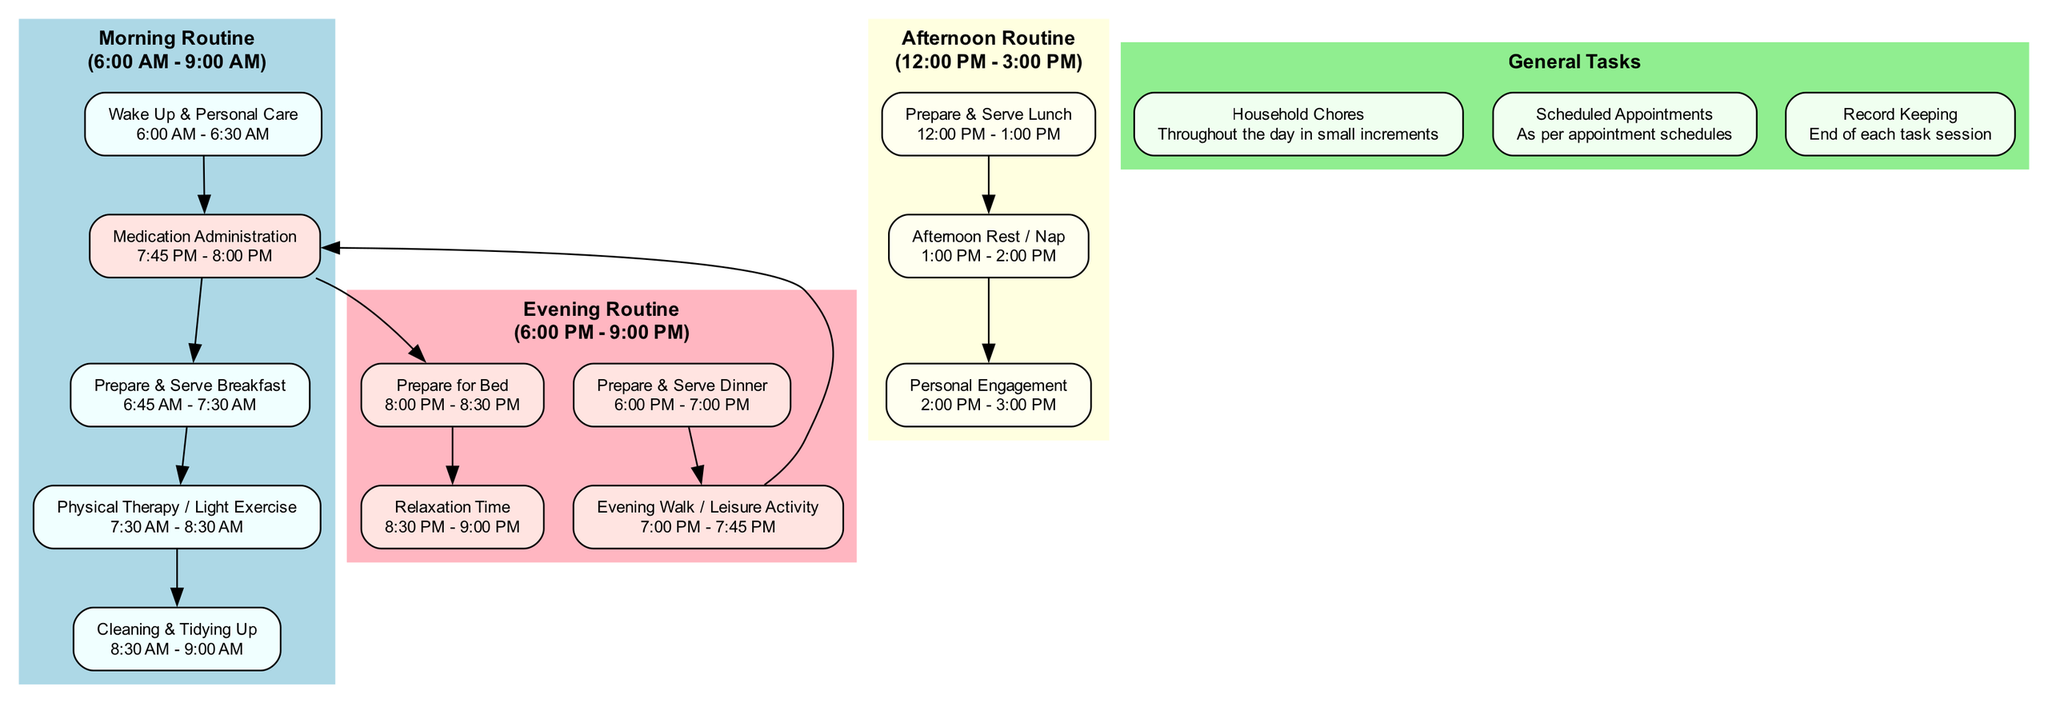What is the time frame for the morning routine? The morning routine is outlined in the diagram with a specific time frame that clearly states "6:00 AM - 9:00 AM".
Answer: 6:00 AM - 9:00 AM How many tasks are listed in the afternoon routine? By counting the tasks presented in the afternoon routine section, we see there are three distinct tasks detailed: "Prepare & Serve Lunch", "Afternoon Rest / Nap", and "Personal Engagement".
Answer: 3 What comes after "Medication Administration" in the evening routine? The flow of tasks in the evening routine shows "Medication Administration" leading directly to "Prepare for Bed". This is indicated by the edge connecting these two tasks in the diagram.
Answer: Prepare for Bed What is one of the general tasks mentioned in the diagram? From the general tasks listed, one specific task is "Household Chores", as it is prominently displayed in the general tasks section of the diagram.
Answer: Household Chores What is the total number of tasks in the morning routine? By analyzing the morning routine section, we count five tasks: "Wake Up & Personal Care", "Medication Administration", "Prepare & Serve Breakfast", "Physical Therapy / Light Exercise", and "Cleaning & Tidying Up".
Answer: 5 What type of activity is suggested during the afternoon rest? The diagram elaborates that the suggested activity during the afternoon rest time is "Ensure care recipient rests or naps", which indicates a focus on rest for both the caregiver and care recipient.
Answer: Nap Which task follows "Evening Walk / Leisure Activity"? In the evening routine, after "Evening Walk / Leisure Activity", the next task listed is "Medication Administration", which directly succeeds it in the sequence of tasks in the diagram.
Answer: Medication Administration Which color represents the morning routine in the diagram? The morning routine section is filled with a distinct color that is identified as "lightblue", making it easily recognizable in the diagram's layout.
Answer: lightblue 